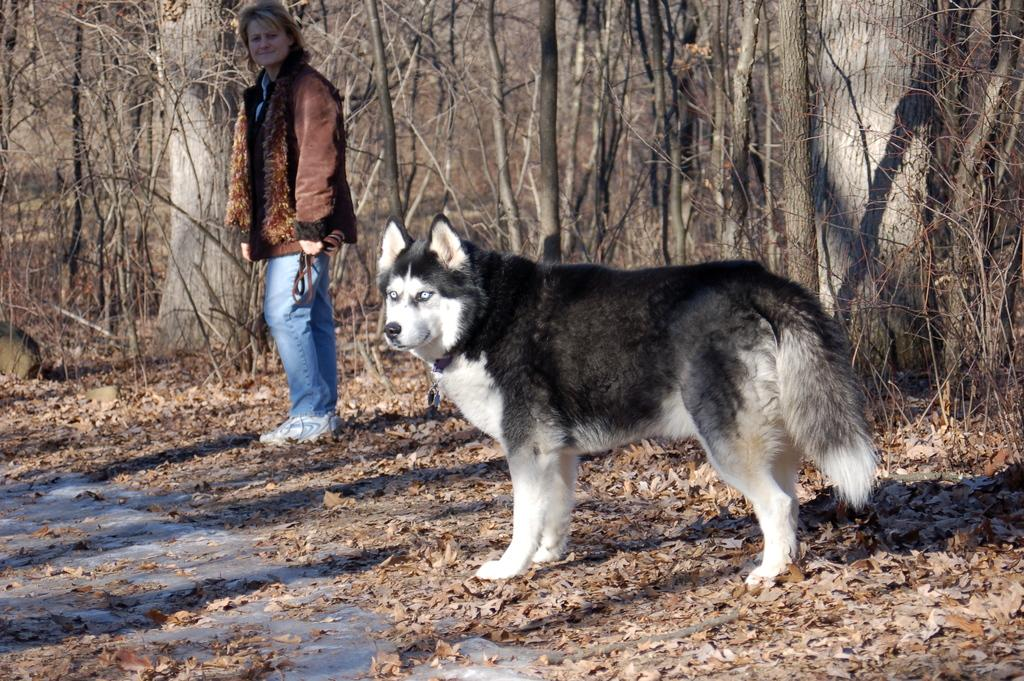What type of animal can be seen in the image? There is a dog in the image. What is the lady wearing in the image? The lady is wearing a jacket in the image. What object is the lady holding in the image? The lady is holding a belt in the image. What can be found on the ground in the image? There are leaves on the ground in the image. What is visible in the background of the image? There are trees visible in the background of the image. What route is the dog taking to the airport in the image? There is no mention of a route or an airport in the image; it only shows a dog and a lady with a jacket and a belt. Is there a bear visible in the image? No, there is no bear present in the image. 